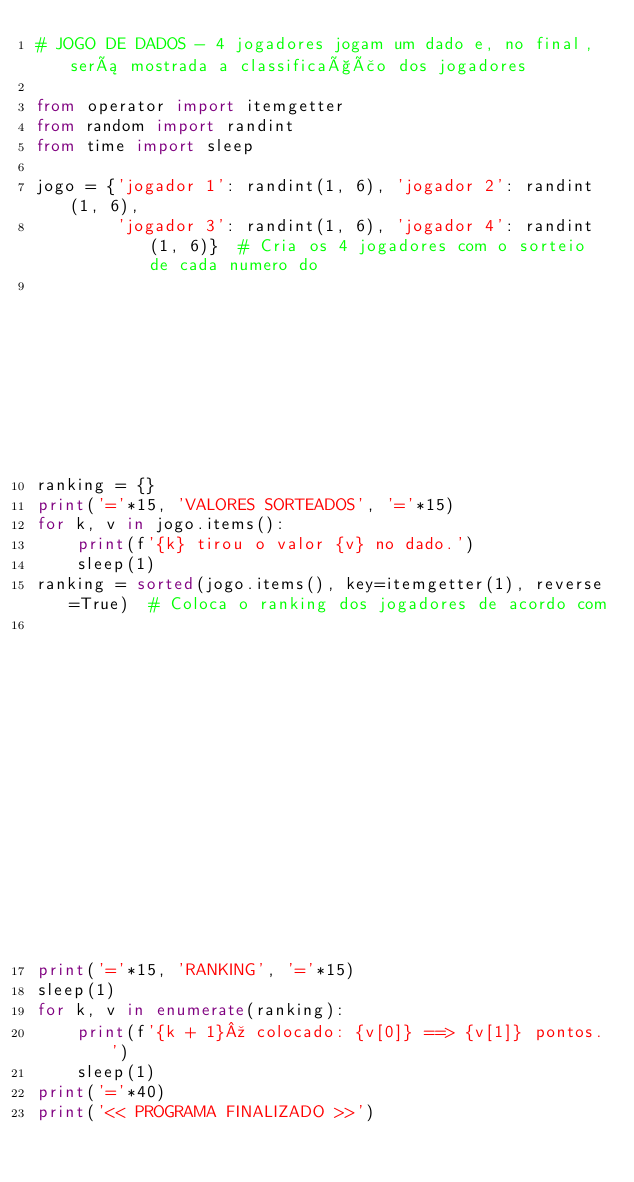Convert code to text. <code><loc_0><loc_0><loc_500><loc_500><_Python_># JOGO DE DADOS - 4 jogadores jogam um dado e, no final, será mostrada a classificação dos jogadores

from operator import itemgetter
from random import randint
from time import sleep

jogo = {'jogador 1': randint(1, 6), 'jogador 2': randint(1, 6),
        'jogador 3': randint(1, 6), 'jogador 4': randint(1, 6)}  # Cria os 4 jogadores com o sorteio de cada numero do
                                                                    # dado para cada jogador
ranking = {}
print('='*15, 'VALORES SORTEADOS', '='*15)
for k, v in jogo.items():
    print(f'{k} tirou o valor {v} no dado.')
    sleep(1)
ranking = sorted(jogo.items(), key=itemgetter(1), reverse=True)  # Coloca o ranking dos jogadores de acordo com
                                                                # a pontuação. Maior pontuação >> menor pontuação
print('='*15, 'RANKING', '='*15)
sleep(1)
for k, v in enumerate(ranking):
    print(f'{k + 1}º colocado: {v[0]} ==> {v[1]} pontos.')
    sleep(1)
print('='*40)
print('<< PROGRAMA FINALIZADO >>')
</code> 